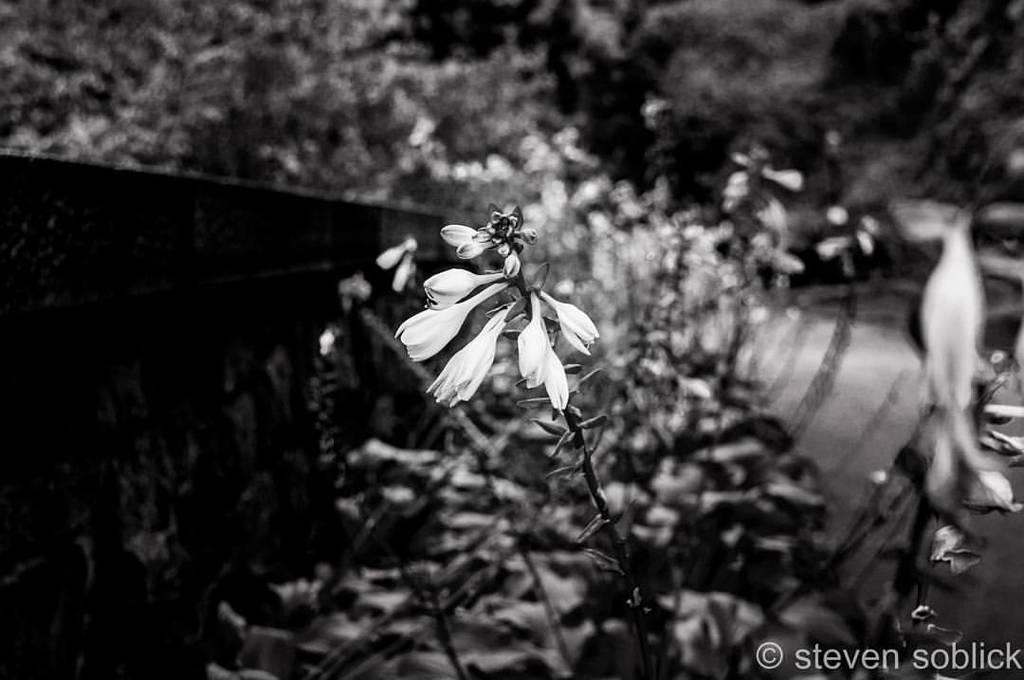What can be seen in the bottom left corner of the image? There is a watermark on the bottom left of the image. What is the main subject of the image? There is a plant with flowers in the middle of the image. How would you describe the background of the image? The background of the image is blurred. How many chickens are present in the image? There are no chickens present in the image. What type of cactus can be seen in the image? There is no cactus present in the image; it features a plant with flowers. 